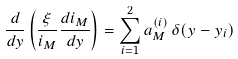<formula> <loc_0><loc_0><loc_500><loc_500>\frac { d } { d y } \left ( \frac { \xi } { i _ { M } } \frac { d i _ { M } } { d y } \right ) = \sum _ { i = 1 } ^ { 2 } a ^ { ( i ) } _ { M } \, \delta ( y - y _ { i } )</formula> 